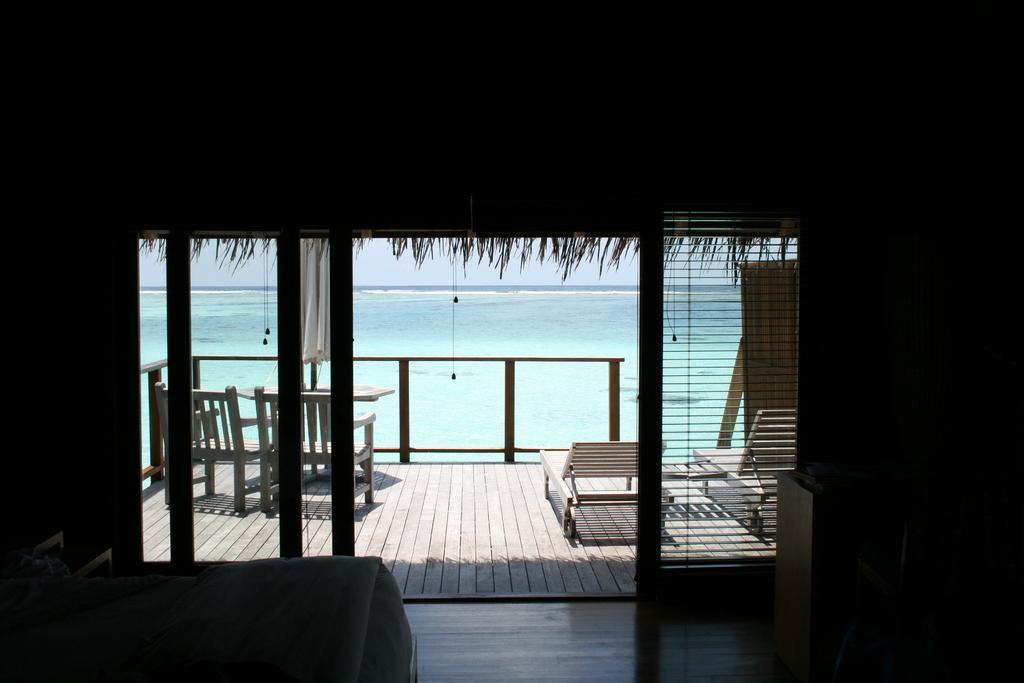Could you give a brief overview of what you see in this image? In this image I can see the dark picture in which I can see a bed, a wooden floor, few chairs, a table, the railing, a beach bed, an umbrella and in the background I can see the water and the sky. 